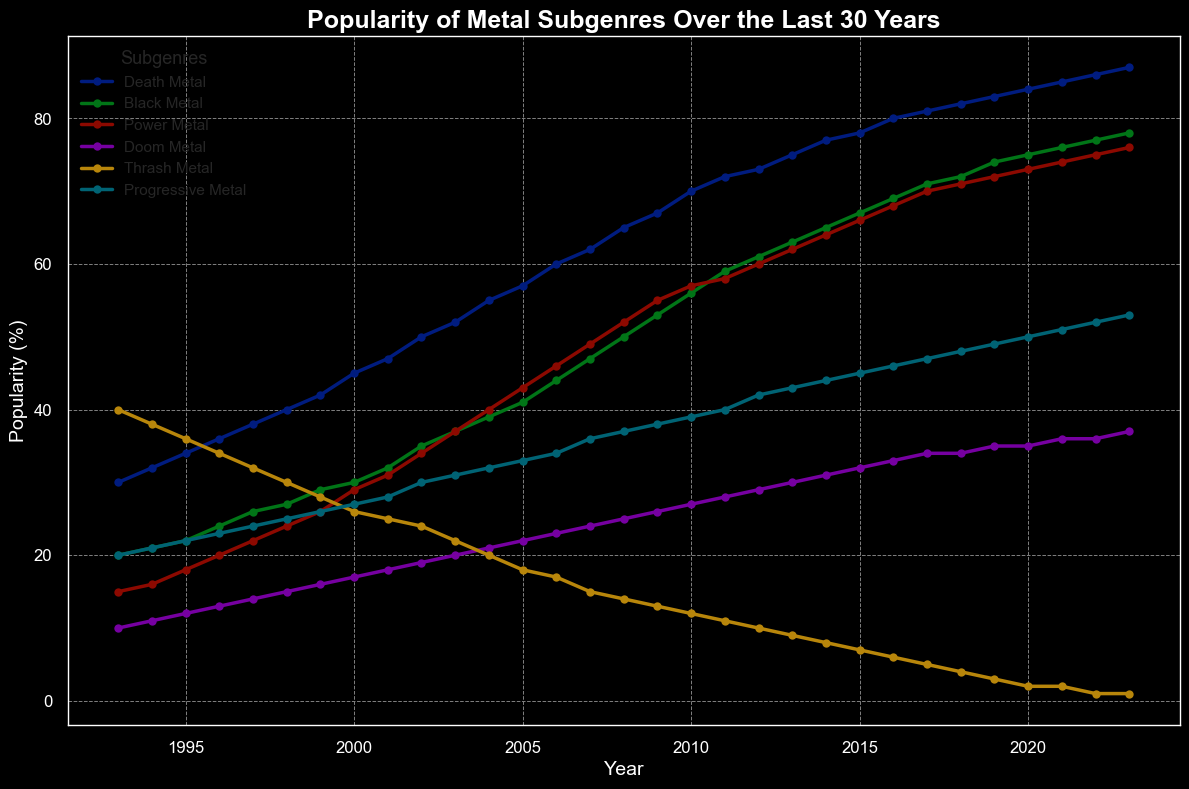Which subgenre started with the lowest popularity in 1993? To determine which subgenre had the lowest popularity in 1993, we look at the data for each subgenre for that year. The values are Death Metal: 30, Black Metal: 20, Power Metal: 15, Doom Metal: 10, Thrash Metal: 40, and Progressive Metal: 20. Here, Doom Metal has the lowest value of 10.
Answer: Doom Metal What is the difference in popularity between Death Metal and Thrash Metal in 2023? To find the difference in popularity between Death Metal and Thrash Metal in 2023, we need the values for both subgenres in that year. For 2023, Death Metal is at 87 and Thrash Metal is at 1. The difference is calculated as 87 - 1.
Answer: 86 Which year did Power Metal's popularity surpass Doom Metal's popularity? To find the year when Power Metal's popularity first surpassed Doom Metal's, we compare the trends for both subgenres year by year. In 1993, Power Metal is at 15 and Doom Metal is at 10. Power Metal consistently has higher values starting from 1993. Since 1993 is the first year in the data, Power Metal has always been more popular than Doom Metal.
Answer: 1993 In which year did Death Metal achieve at least twice the popularity of Power Metal? To determine when Death Metal's popularity became at least twice that of Power Metal, we need to find the earliest year where Death Metal's value is at least twice that of Power Metal's. By inspecting the values, we see that in 1994, Death Metal has 32 and Power Metal has 16; 32 is exactly twice 16.
Answer: 1994 By how much did the popularity of Progressive Metal increase from 2000 to 2023? To find the increase in popularity of Progressive Metal from 2000 to 2023, we subtract the value in 2000 from the value in 2023. For Progressive Metal, the values are 27 in 2000 and 53 in 2023. The difference is 53 - 27.
Answer: 26 Which subgenre showed a continuous decline in popularity from 1993 to 2023? To find which subgenre continuously declined, we need to look at the trends for each subgenre over the years. Thrash Metal starts at 40 in 1993 and declines every year, reaching 1 in 2023. No other subgenre shows a continuous decline.
Answer: Thrash Metal What was the overall trend for Black Metal from 1993 to 2023? To determine the overall trend for Black Metal, we look at its values from 1993 to 2023. Starting at 20 in 1993 and rising to 78 in 2023, it shows a consistent upward trend.
Answer: Upward Trend Are there any years where two subgenres have the same popularity? To find if any subgenres have the same popularity in the same year, we compare each subgenre's values for each year. There are no years in this dataset where two subgenres have the exact same popularity.
Answer: No 